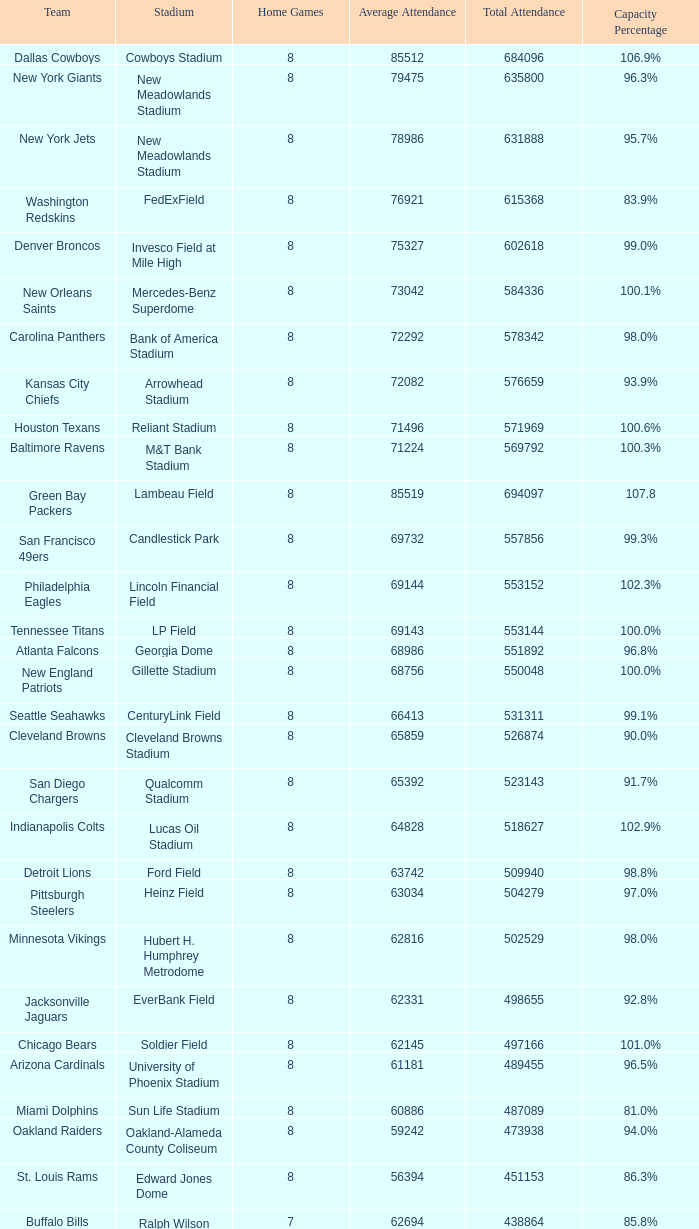With an average attendance of 79,475, how many home games can be found on the list? 1.0. 